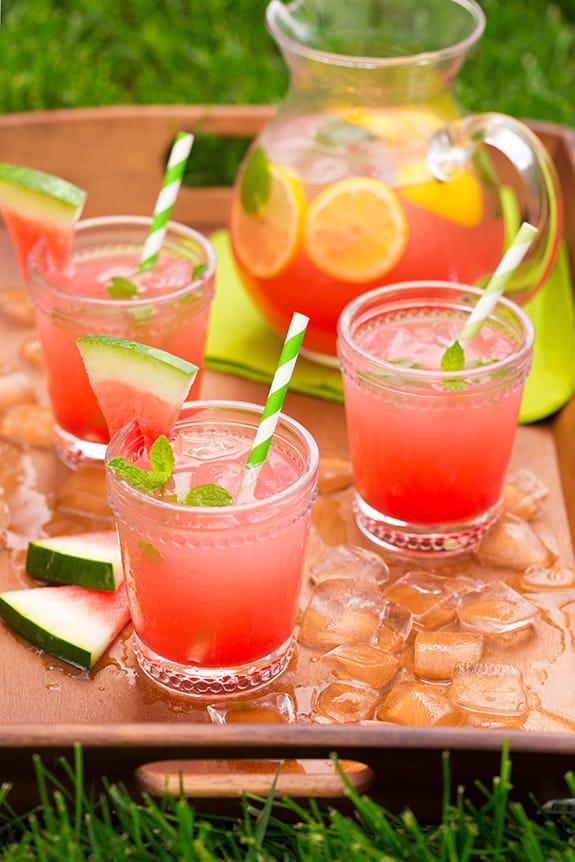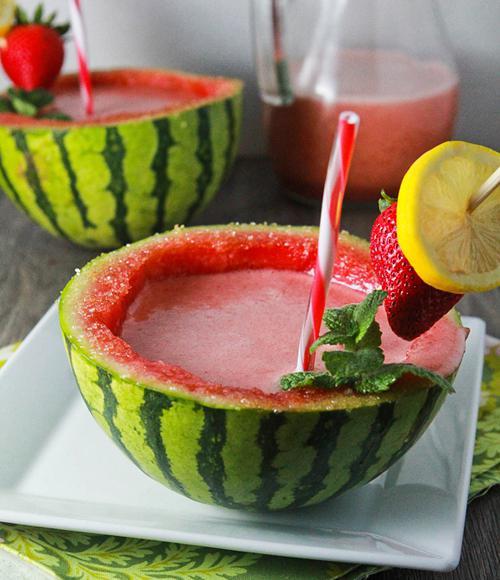The first image is the image on the left, the second image is the image on the right. Evaluate the accuracy of this statement regarding the images: "All drink servings are garnished with striped straws.". Is it true? Answer yes or no. Yes. The first image is the image on the left, the second image is the image on the right. Evaluate the accuracy of this statement regarding the images: "Left image shows glasses garnished with a thin watermelon slice.". Is it true? Answer yes or no. Yes. 